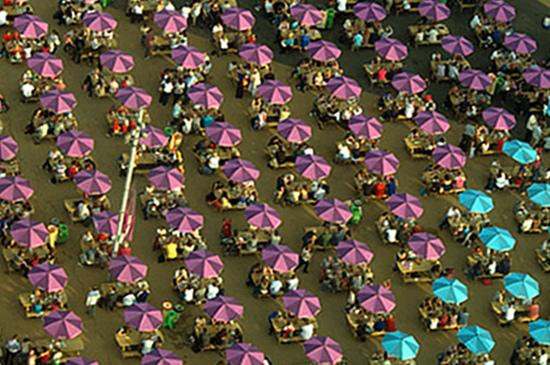Is the umbrella blue?
Concise answer only. Yes. How many umbrellas are there?
Keep it brief. Many. There are two different colored umbrellas. What are they?
Keep it brief. Purple and blue. Are these wild flowers?
Answer briefly. No. How many purple umbrella is there?
Write a very short answer. 60. 